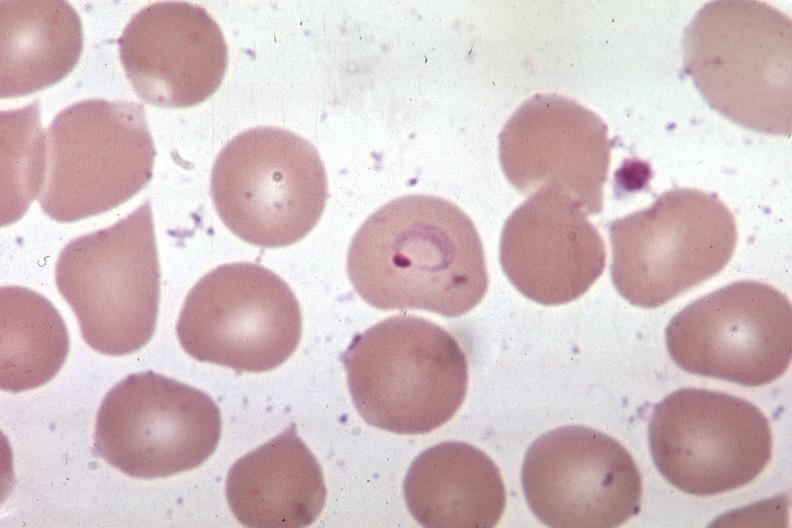what is present?
Answer the question using a single word or phrase. Malaria plasmodium vivax 